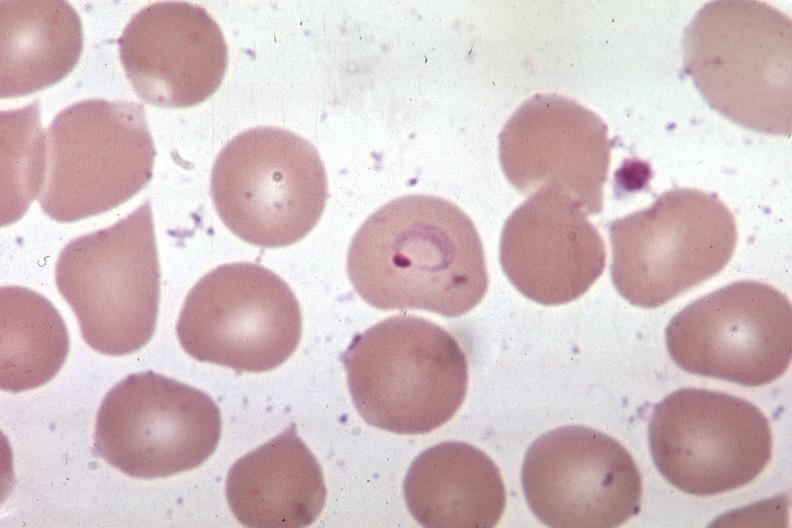what is present?
Answer the question using a single word or phrase. Malaria plasmodium vivax 